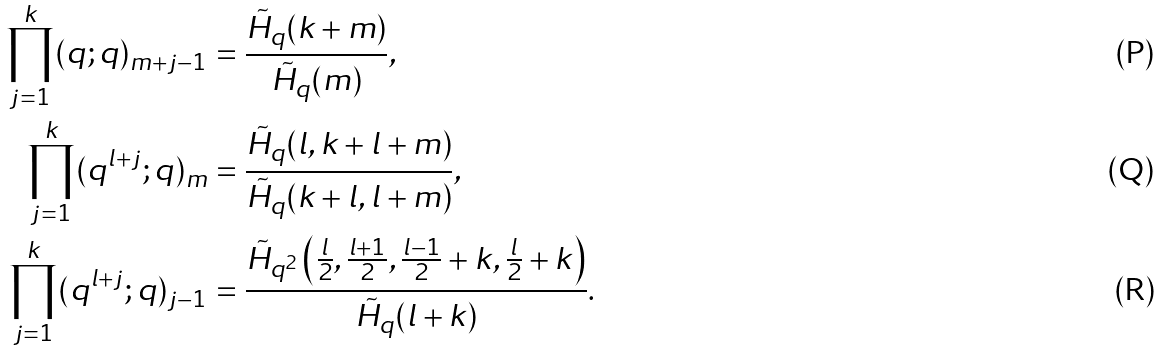Convert formula to latex. <formula><loc_0><loc_0><loc_500><loc_500>\prod _ { j = 1 } ^ { k } ( q ; q ) _ { m + j - 1 } & = \frac { \tilde { H } _ { q } ( k + m ) } { \tilde { H } _ { q } ( m ) } , \\ \prod _ { j = 1 } ^ { k } ( q ^ { l + j } ; q ) _ { m } & = \frac { \tilde { H } _ { q } ( l , k + l + m ) } { \tilde { H } _ { q } ( k + l , l + m ) } , \\ \prod _ { j = 1 } ^ { k } ( q ^ { l + j } ; q ) _ { j - 1 } & = \frac { \tilde { H } _ { q ^ { 2 } } \left ( \frac { l } { 2 } , \frac { l + 1 } 2 , \frac { l - 1 } { 2 } + k , \frac { l } { 2 } + k \right ) } { \tilde { H } _ { q } ( l + k ) } .</formula> 